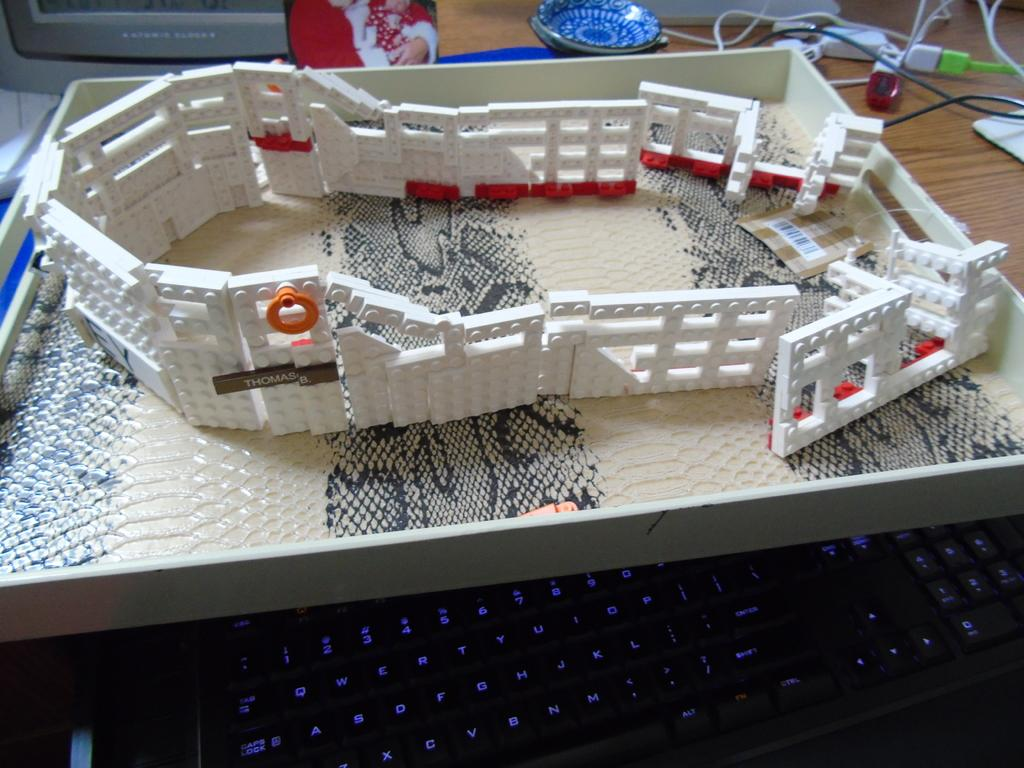What is being built in the image? There is a blocks building in the image. What is the blocks building placed on? The blocks building is on a box. What other object can be seen in the image? There is a plate in the image. Where are the wires located in the image? The wires are on a table. What is the purpose of the wires? The wires are likely connected to the keyboard, which is also present in the image. What type of bread is being toasted on the plate in the image? There is no bread present in the image; it features a blocks building, a plate, wires, and a keyboard. 